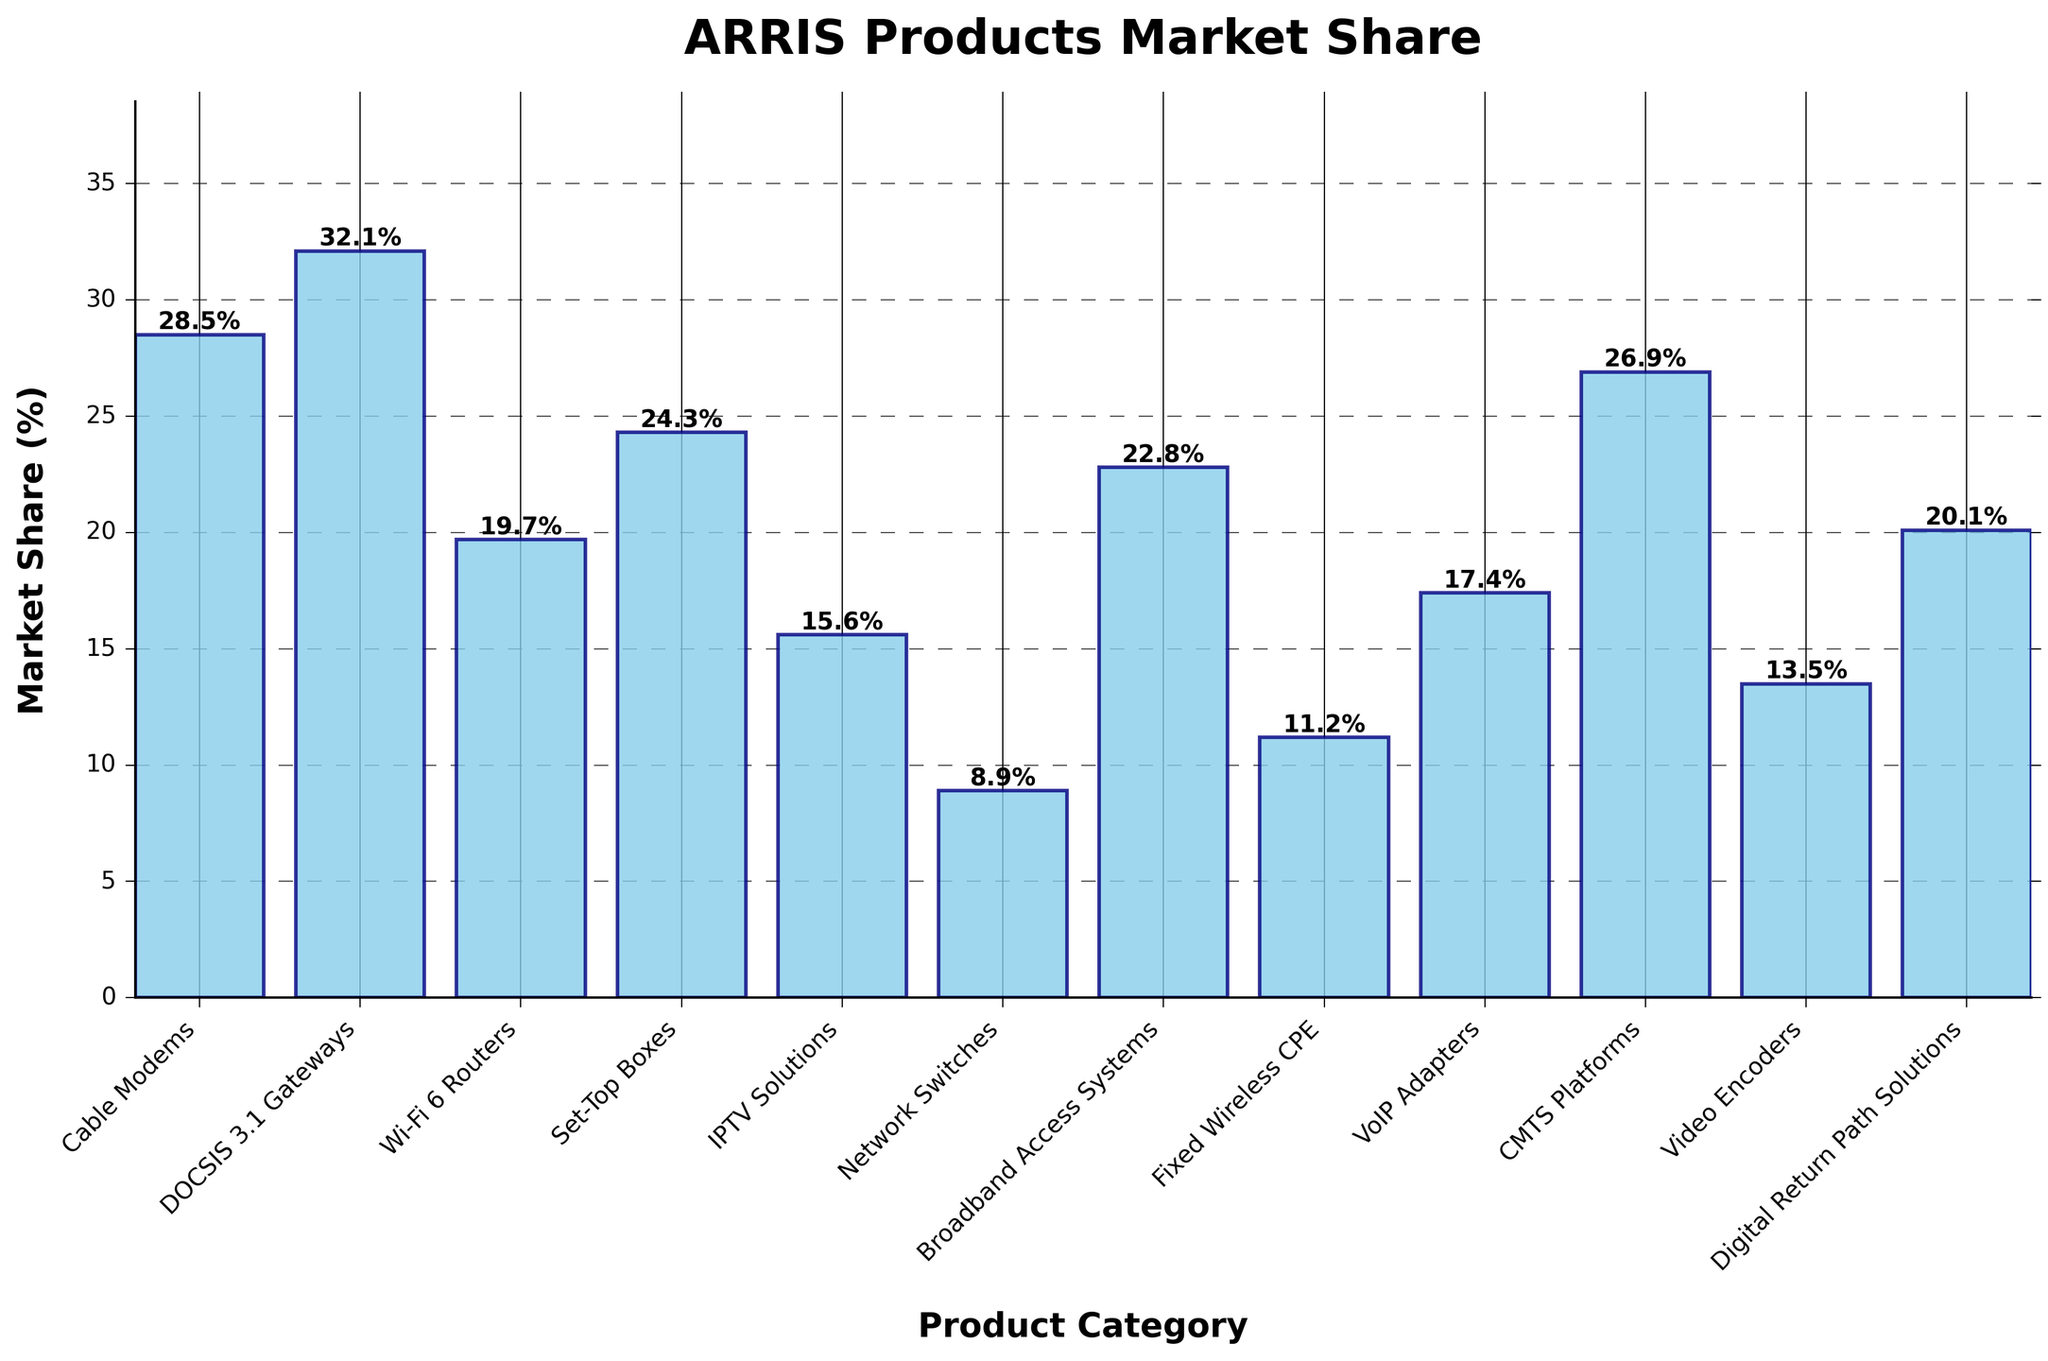What's the average market share of DOCSIS 3.1 Gateways, Wi-Fi 6 Routers, and Set-Top Boxes? To find the average market share, we sum the market shares of DOCSIS 3.1 Gateways (32.1%), Wi-Fi 6 Routers (19.7%), and Set-Top Boxes (24.3%), and then divide by 3. (32.1 + 19.7 + 24.3) = 76.1; 76.1 / 3 = 25.4
Answer: 25.4% Which product category has the highest market share? By looking at the heights of the bars, DOCSIS 3.1 Gateways have the highest market share at 32.1%.
Answer: DOCSIS 3.1 Gateways What is the difference in market share between Cable Modems and Network Switches? The market share of Cable Modems is 28.5%, and the market share of Network Switches is 8.9%. So, the difference is calculated as 28.5 - 8.9 = 19.6.
Answer: 19.6% Which product category has slightly lower market share than Cable Modems? From the bar heights, CMTS Platforms with a market share of 26.9% are just slightly lower than the 28.5% share of Cable Modems.
Answer: CMTS Platforms How many product categories have a market share greater than 20%? By analyzing the bar heights, the categories with a market share greater than 20% are Cable Modems, DOCSIS 3.1 Gateways, Set-Top Boxes, CMTS Platforms, and Digital Return Path Solutions. There are 5 such categories.
Answer: 5 What is the combined market share of VoIP Adapters, Fixed Wireless CPE, and IPTV Solutions? Add the market shares of VoIP Adapters (17.4%), Fixed Wireless CPE (11.2%), and IPTV Solutions (15.6%). 17.4 + 11.2 + 15.6 = 44.2.
Answer: 44.2% Which product category has the shortest bar in the chart? The shortest bar corresponds to Network Switches, which have the lowest market share at 8.9%.
Answer: Network Switches Is the market share of Broadband Access Systems closer to the market share of Set-Top Boxes or DOCSIS 3.1 Gateways? Broadband Access Systems have a market share of 22.8%. Set-Top Boxes have 24.3%, and DOCSIS 3.1 Gateways have 32.1%. The difference between Broadband Access Systems and Set-Top Boxes is 24.3 - 22.8 = 1.5. The difference between Broadband Access Systems and DOCSIS 3.1 Gateways is 32.1 - 22.8 = 9.3. Therefore, 22.8 is closer to 24.3.
Answer: Set-Top Boxes Which two product categories have a combined market share that is most similar to 40%? By checking combinations of bars visually, the combination of Wi-Fi 6 Routers (19.7%) and Digital Return Path Solutions (20.1%) give a combined market share of 19.7 + 20.1 = 39.8%, which is most similar to 40%.
Answer: Wi-Fi 6 Routers and Digital Return Path Solutions 